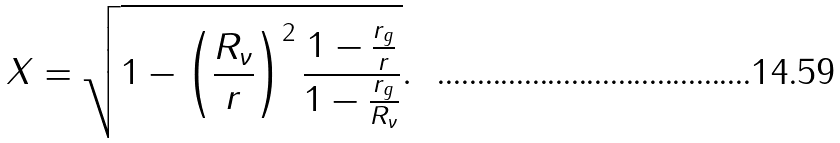Convert formula to latex. <formula><loc_0><loc_0><loc_500><loc_500>X = \sqrt { 1 - \left ( \frac { R _ { \nu } } { r } \right ) ^ { 2 } \frac { 1 - \frac { r _ { g } } { r } } { 1 - \frac { r _ { g } } { R _ { \nu } } } } .</formula> 